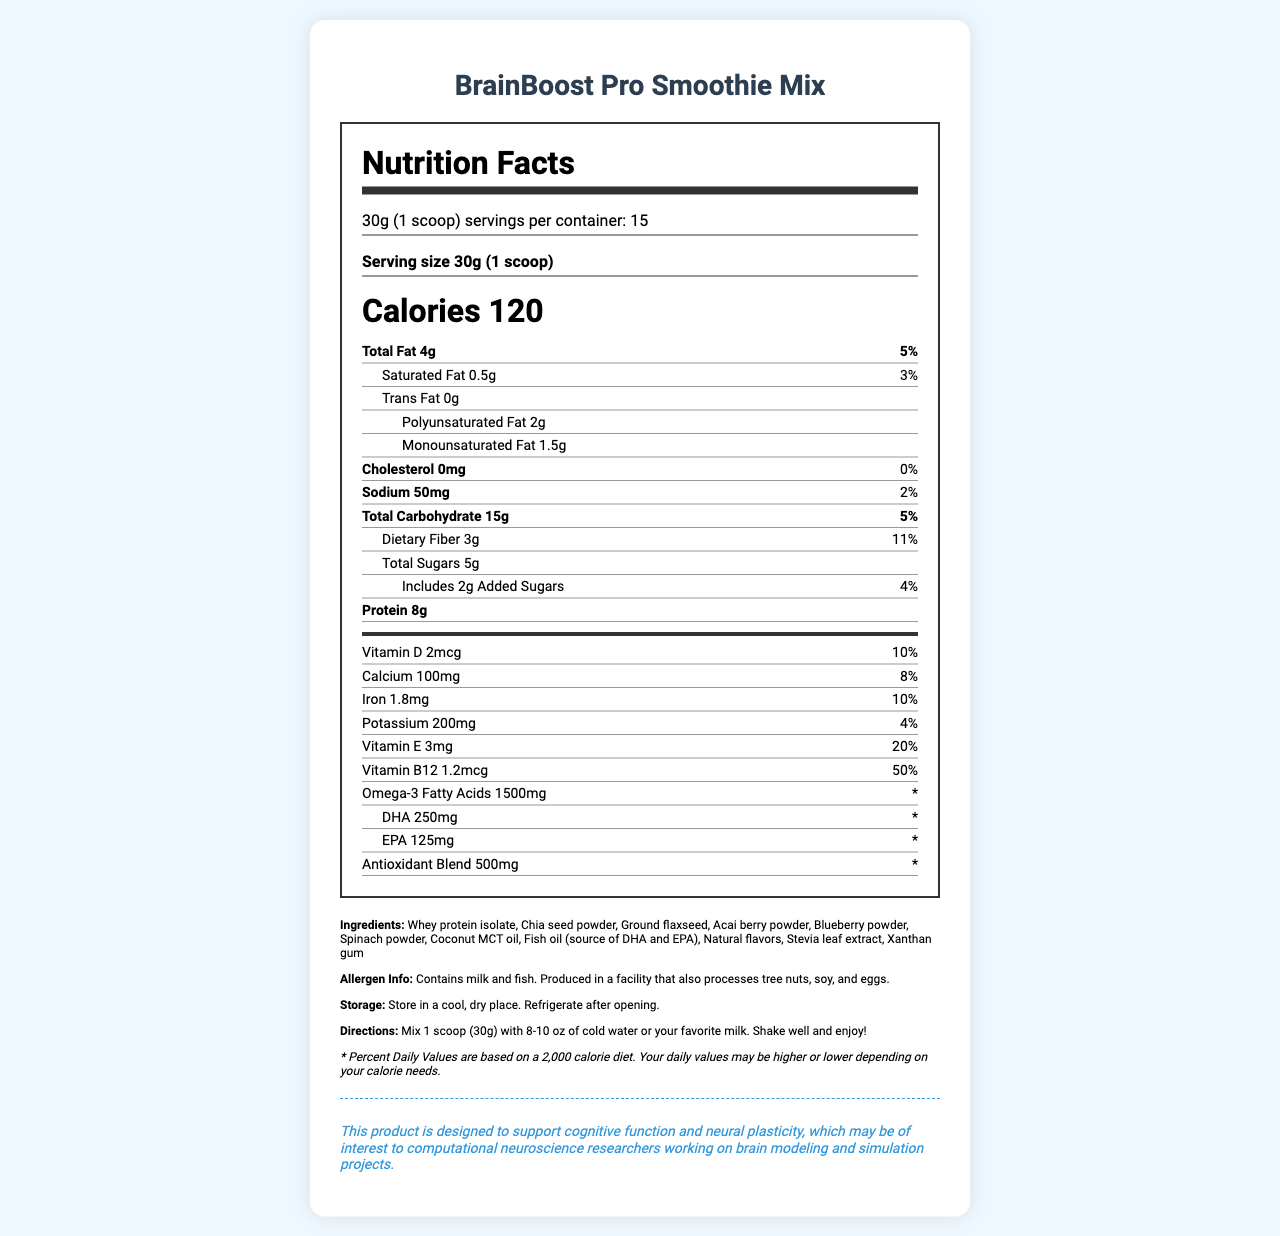what is the serving size? The serving size is clearly mentioned as "30g (1 scoop)" in the document.
Answer: 30g (1 scoop) how many calories are in a single serving? The document states that there are 120 calories per serving.
Answer: 120 what is the percentage of daily value for Vitamin B12 in one serving? The document lists Vitamin B12 with a daily value percentage of 50%.
Answer: 50% how much total fat is in one serving and what is its daily value percentage? The document specifies that one serving contains 4g of total fat, which is 5% of the daily value.
Answer: 4g, 5% list three main ingredients of this smoothie mix. The ingredients are listed in the document, and these three are the first mentioned.
Answer: Whey protein isolate, Chia seed powder, Ground flaxseed how many servings per container are there? A. 10 B. 15 C. 20 The document clearly states there are 15 servings per container.
Answer: B what amount of dietary fiber does one serving provide? A. 1g B. 3g C. 5g D. 7g The document mentions that one serving has 3g of dietary fiber.
Answer: B is this product suitable for someone with a milk allergy? Yes or No The allergen information states that the product contains milk.
Answer: No summarize the main nutritional benefits of this smoothie mix. The document highlights the ingredients, omega-3 fatty acids, antioxidants, vitamins, and minerals, which contribute to cognitive function.
Answer: Supports cognitive function, contains omega-3 fatty acids, antioxidants, and essential vitamins and minerals. what is the main source of omega-3 fatty acids in this product? The document lists fish oil, which is a known source of omega-3 fatty acids (including DHA and EPA).
Answer: Fish oil how many grams of total sugars are in a single serving? According to the document, a single serving contains 5g of total sugars.
Answer: 5g can you determine the specific calorie needs of an individual from this document? The document mentions that the daily values are based on a 2000 calorie diet but does not provide specifics for individual calorie needs.
Answer: Not enough information how much added sugar is in one serving? The document states that there are 2g of added sugars in one serving.
Answer: 2g what is the recommended storage method for this product? The document includes storage instructions that specify storing in a cool, dry place and refrigerating after opening.
Answer: Store in a cool, dry place. Refrigerate after opening. 